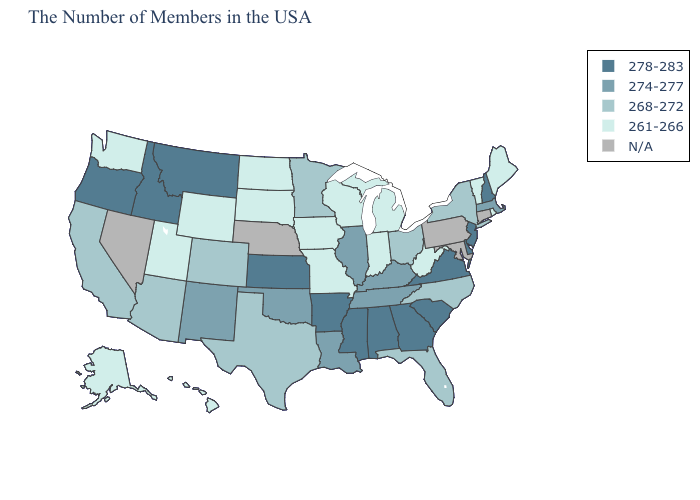Does Colorado have the highest value in the West?
Quick response, please. No. Name the states that have a value in the range 268-272?
Give a very brief answer. New York, North Carolina, Ohio, Florida, Minnesota, Texas, Colorado, Arizona, California. Name the states that have a value in the range N/A?
Quick response, please. Connecticut, Maryland, Pennsylvania, Nebraska, Nevada. Name the states that have a value in the range 278-283?
Be succinct. New Hampshire, New Jersey, Delaware, Virginia, South Carolina, Georgia, Alabama, Mississippi, Arkansas, Kansas, Montana, Idaho, Oregon. What is the highest value in the MidWest ?
Be succinct. 278-283. Name the states that have a value in the range N/A?
Answer briefly. Connecticut, Maryland, Pennsylvania, Nebraska, Nevada. Does Illinois have the highest value in the USA?
Be succinct. No. Which states have the highest value in the USA?
Quick response, please. New Hampshire, New Jersey, Delaware, Virginia, South Carolina, Georgia, Alabama, Mississippi, Arkansas, Kansas, Montana, Idaho, Oregon. Does Hawaii have the highest value in the West?
Short answer required. No. What is the lowest value in the South?
Short answer required. 261-266. What is the highest value in the MidWest ?
Answer briefly. 278-283. What is the highest value in states that border North Carolina?
Answer briefly. 278-283. Which states hav the highest value in the Northeast?
Answer briefly. New Hampshire, New Jersey. What is the value of Wisconsin?
Answer briefly. 261-266. What is the value of California?
Write a very short answer. 268-272. 